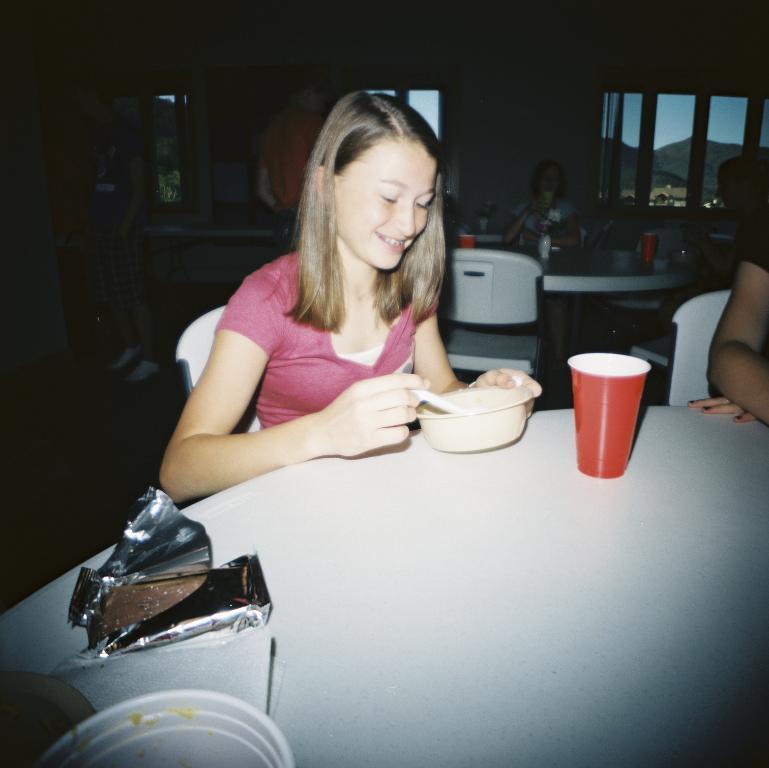In one or two sentences, can you explain what this image depicts? A girl with pink t-shirt is sitting on a chair. She is smiling. In her hand there is a bowl. In front of her there is a table. On the table there is a packet and a glass. Behind her there is a table, chair , a lady and a window. 